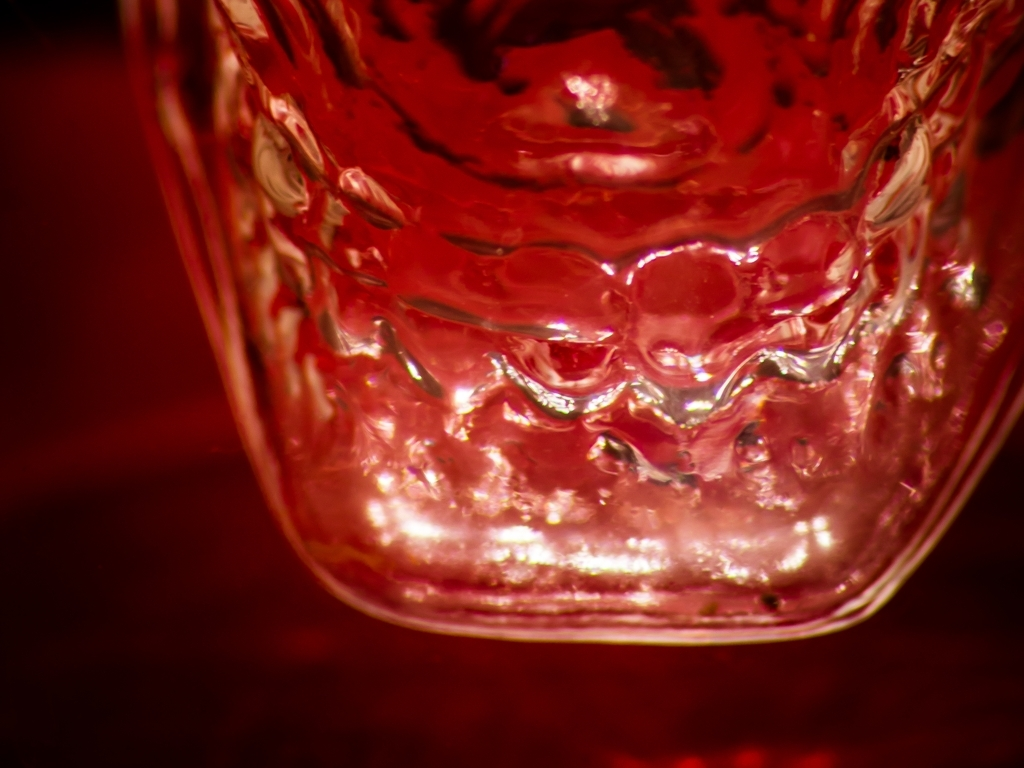Are there any major quality issues in this image? After thorough inspection, the image appears to be clear without any significant issues affecting its quality. The focus is sharp, and the colors are vibrant, which suggests a correctly executed capture process. 